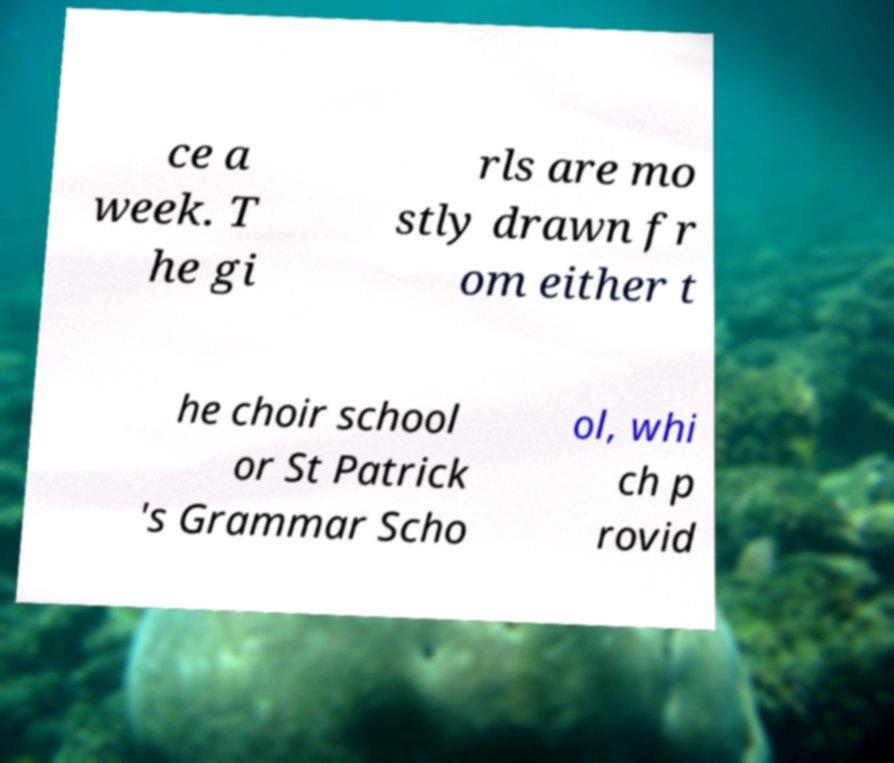There's text embedded in this image that I need extracted. Can you transcribe it verbatim? ce a week. T he gi rls are mo stly drawn fr om either t he choir school or St Patrick 's Grammar Scho ol, whi ch p rovid 